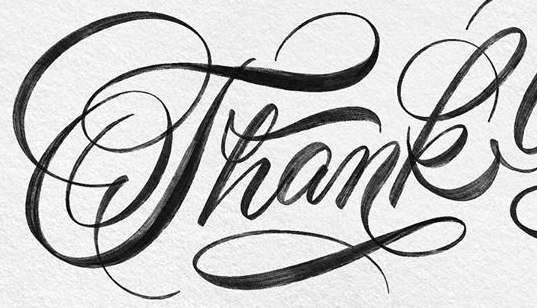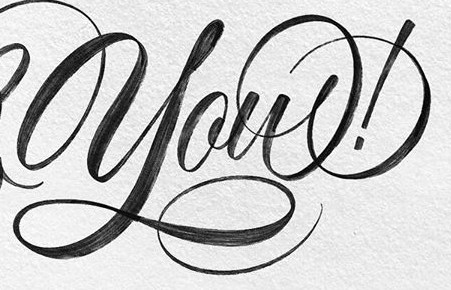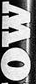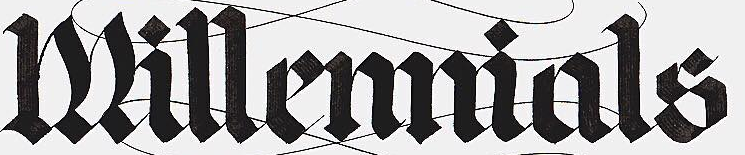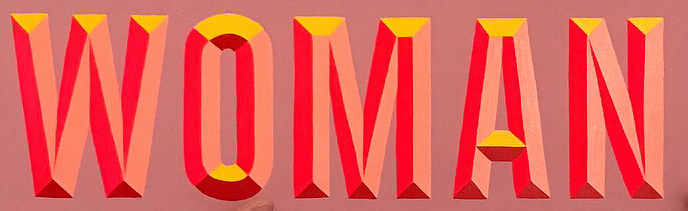What words can you see in these images in sequence, separated by a semicolon? Thank; you!; MO; Millemmials; WOMAN 